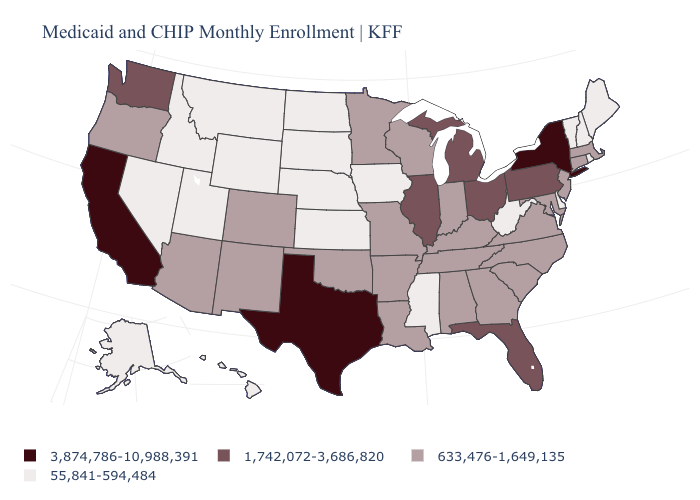Among the states that border Connecticut , does Rhode Island have the lowest value?
Short answer required. Yes. Does the first symbol in the legend represent the smallest category?
Keep it brief. No. Does West Virginia have a higher value than Arkansas?
Write a very short answer. No. Among the states that border South Carolina , which have the highest value?
Be succinct. Georgia, North Carolina. What is the value of Alabama?
Quick response, please. 633,476-1,649,135. Does Tennessee have the same value as Ohio?
Short answer required. No. Which states have the lowest value in the USA?
Write a very short answer. Alaska, Delaware, Hawaii, Idaho, Iowa, Kansas, Maine, Mississippi, Montana, Nebraska, Nevada, New Hampshire, North Dakota, Rhode Island, South Dakota, Utah, Vermont, West Virginia, Wyoming. What is the highest value in the USA?
Write a very short answer. 3,874,786-10,988,391. What is the value of Pennsylvania?
Answer briefly. 1,742,072-3,686,820. What is the value of New York?
Give a very brief answer. 3,874,786-10,988,391. Name the states that have a value in the range 633,476-1,649,135?
Write a very short answer. Alabama, Arizona, Arkansas, Colorado, Connecticut, Georgia, Indiana, Kentucky, Louisiana, Maryland, Massachusetts, Minnesota, Missouri, New Jersey, New Mexico, North Carolina, Oklahoma, Oregon, South Carolina, Tennessee, Virginia, Wisconsin. Is the legend a continuous bar?
Concise answer only. No. Does Kansas have the same value as Iowa?
Concise answer only. Yes. Does Mississippi have a lower value than Indiana?
Keep it brief. Yes. 